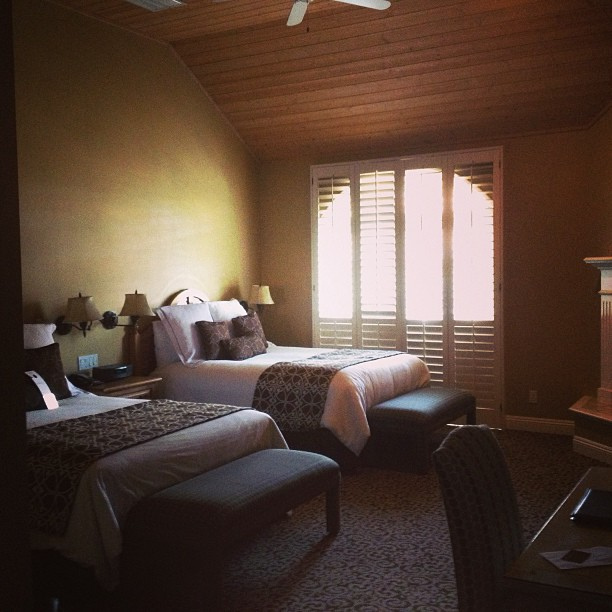<image>What kind of chair is in the lower right hand corner? There is no chair in the lower right hand corner. What kind of chair is in the lower right hand corner? I am not sure what kind of chair is in the lower right hand corner. It can be seen as 'none', 'desk chair', 'desk', 'office chair', or 'computer'. 